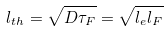<formula> <loc_0><loc_0><loc_500><loc_500>l _ { t h } = \sqrt { D \tau _ { F } } = \sqrt { l _ { e } l _ { F } }</formula> 